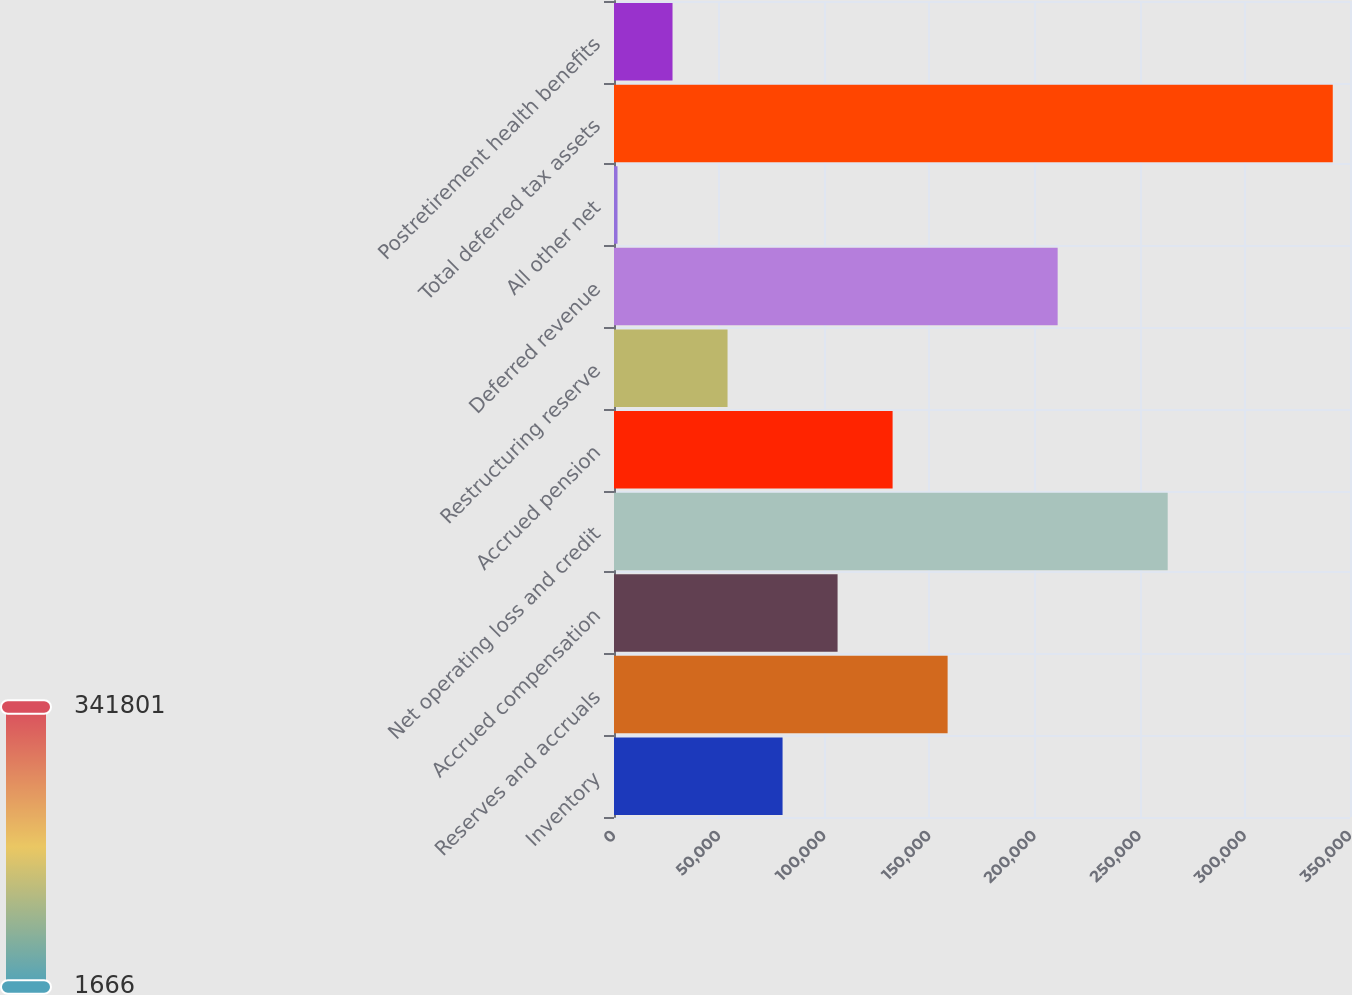<chart> <loc_0><loc_0><loc_500><loc_500><bar_chart><fcel>Inventory<fcel>Reserves and accruals<fcel>Accrued compensation<fcel>Net operating loss and credit<fcel>Accrued pension<fcel>Restructuring reserve<fcel>Deferred revenue<fcel>All other net<fcel>Total deferred tax assets<fcel>Postretirement health benefits<nl><fcel>80158.6<fcel>158651<fcel>106323<fcel>263308<fcel>132487<fcel>53994.4<fcel>210980<fcel>1666<fcel>341801<fcel>27830.2<nl></chart> 